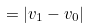<formula> <loc_0><loc_0><loc_500><loc_500>= | v _ { 1 } - v _ { 0 } |</formula> 